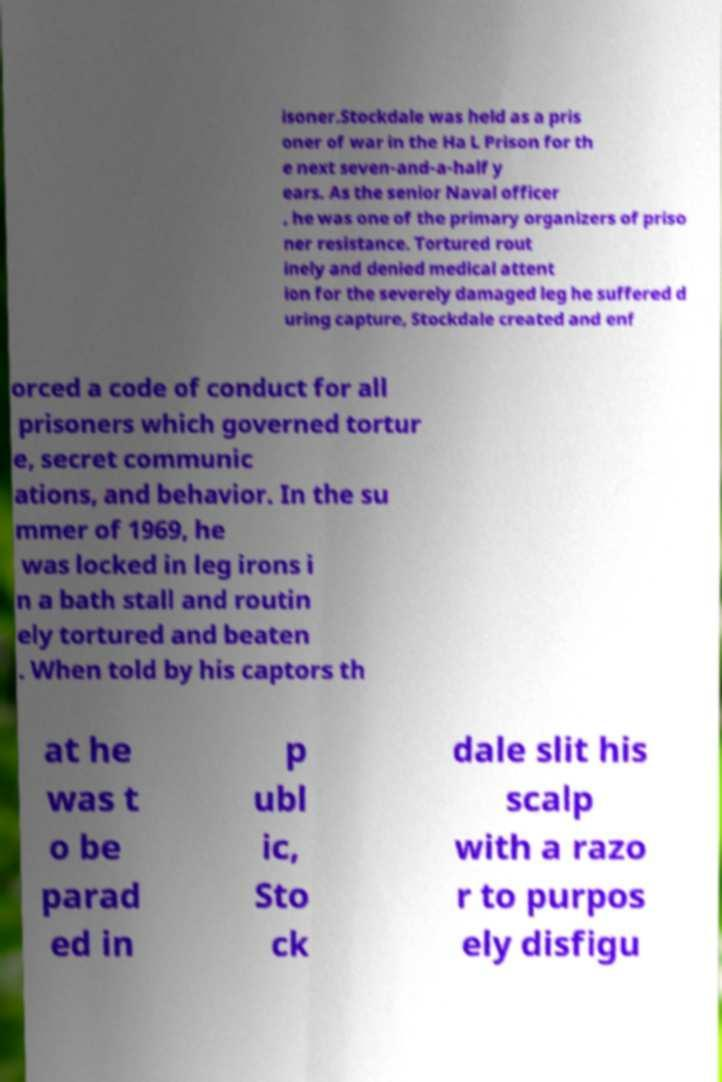Can you read and provide the text displayed in the image?This photo seems to have some interesting text. Can you extract and type it out for me? isoner.Stockdale was held as a pris oner of war in the Ha L Prison for th e next seven-and-a-half y ears. As the senior Naval officer , he was one of the primary organizers of priso ner resistance. Tortured rout inely and denied medical attent ion for the severely damaged leg he suffered d uring capture, Stockdale created and enf orced a code of conduct for all prisoners which governed tortur e, secret communic ations, and behavior. In the su mmer of 1969, he was locked in leg irons i n a bath stall and routin ely tortured and beaten . When told by his captors th at he was t o be parad ed in p ubl ic, Sto ck dale slit his scalp with a razo r to purpos ely disfigu 